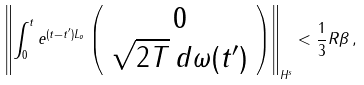Convert formula to latex. <formula><loc_0><loc_0><loc_500><loc_500>\left \| \int _ { 0 } ^ { t } e ^ { ( t - t ^ { \prime } ) L _ { o } } \left ( \begin{array} { c } 0 \\ \sqrt { 2 T } \, d \omega ( t ^ { \prime } ) \end{array} \right ) \right \| _ { H ^ { s } } < \frac { 1 } { 3 } R \beta \, ,</formula> 